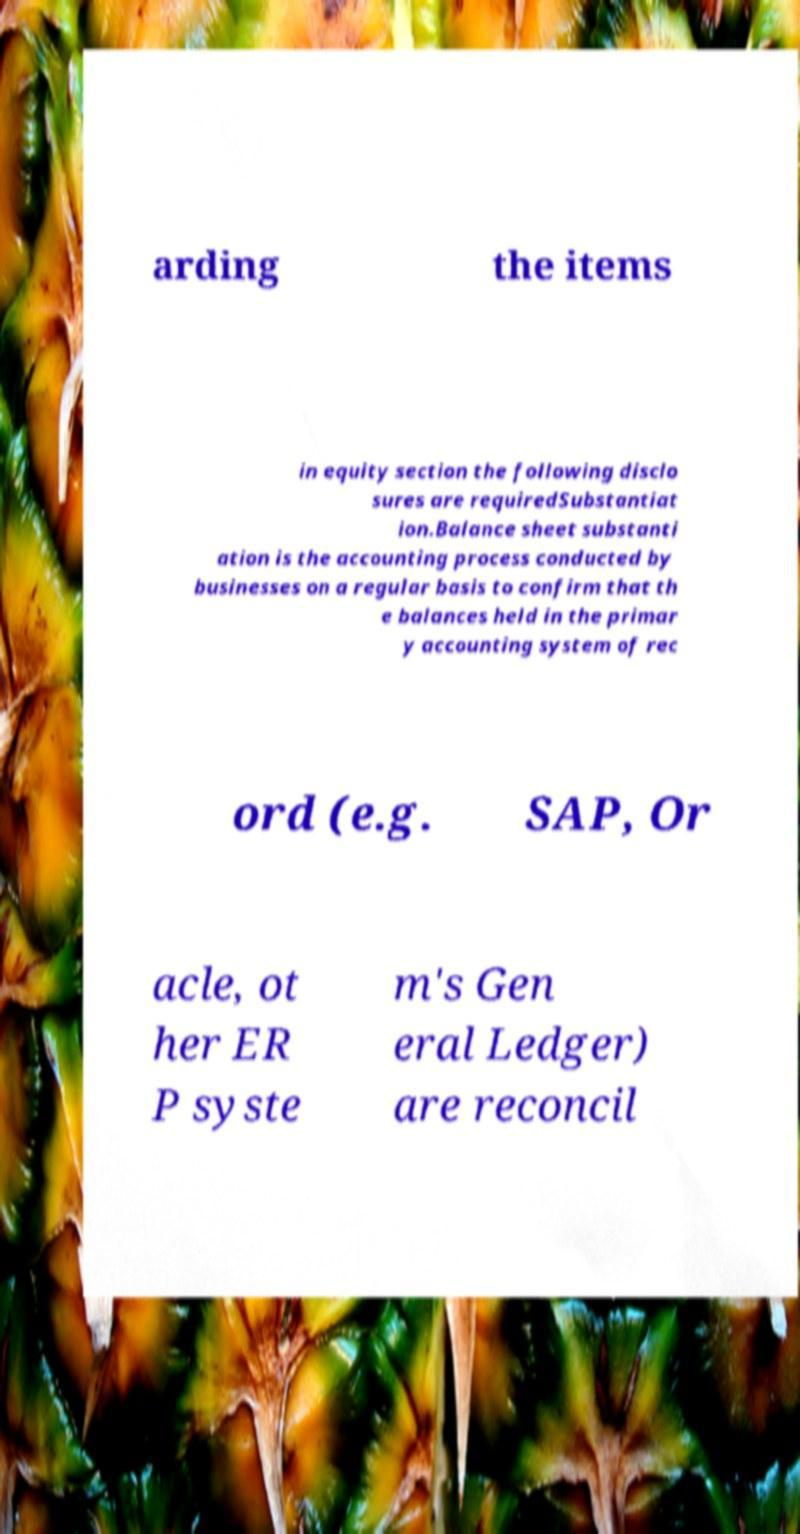Can you accurately transcribe the text from the provided image for me? arding the items in equity section the following disclo sures are requiredSubstantiat ion.Balance sheet substanti ation is the accounting process conducted by businesses on a regular basis to confirm that th e balances held in the primar y accounting system of rec ord (e.g. SAP, Or acle, ot her ER P syste m's Gen eral Ledger) are reconcil 